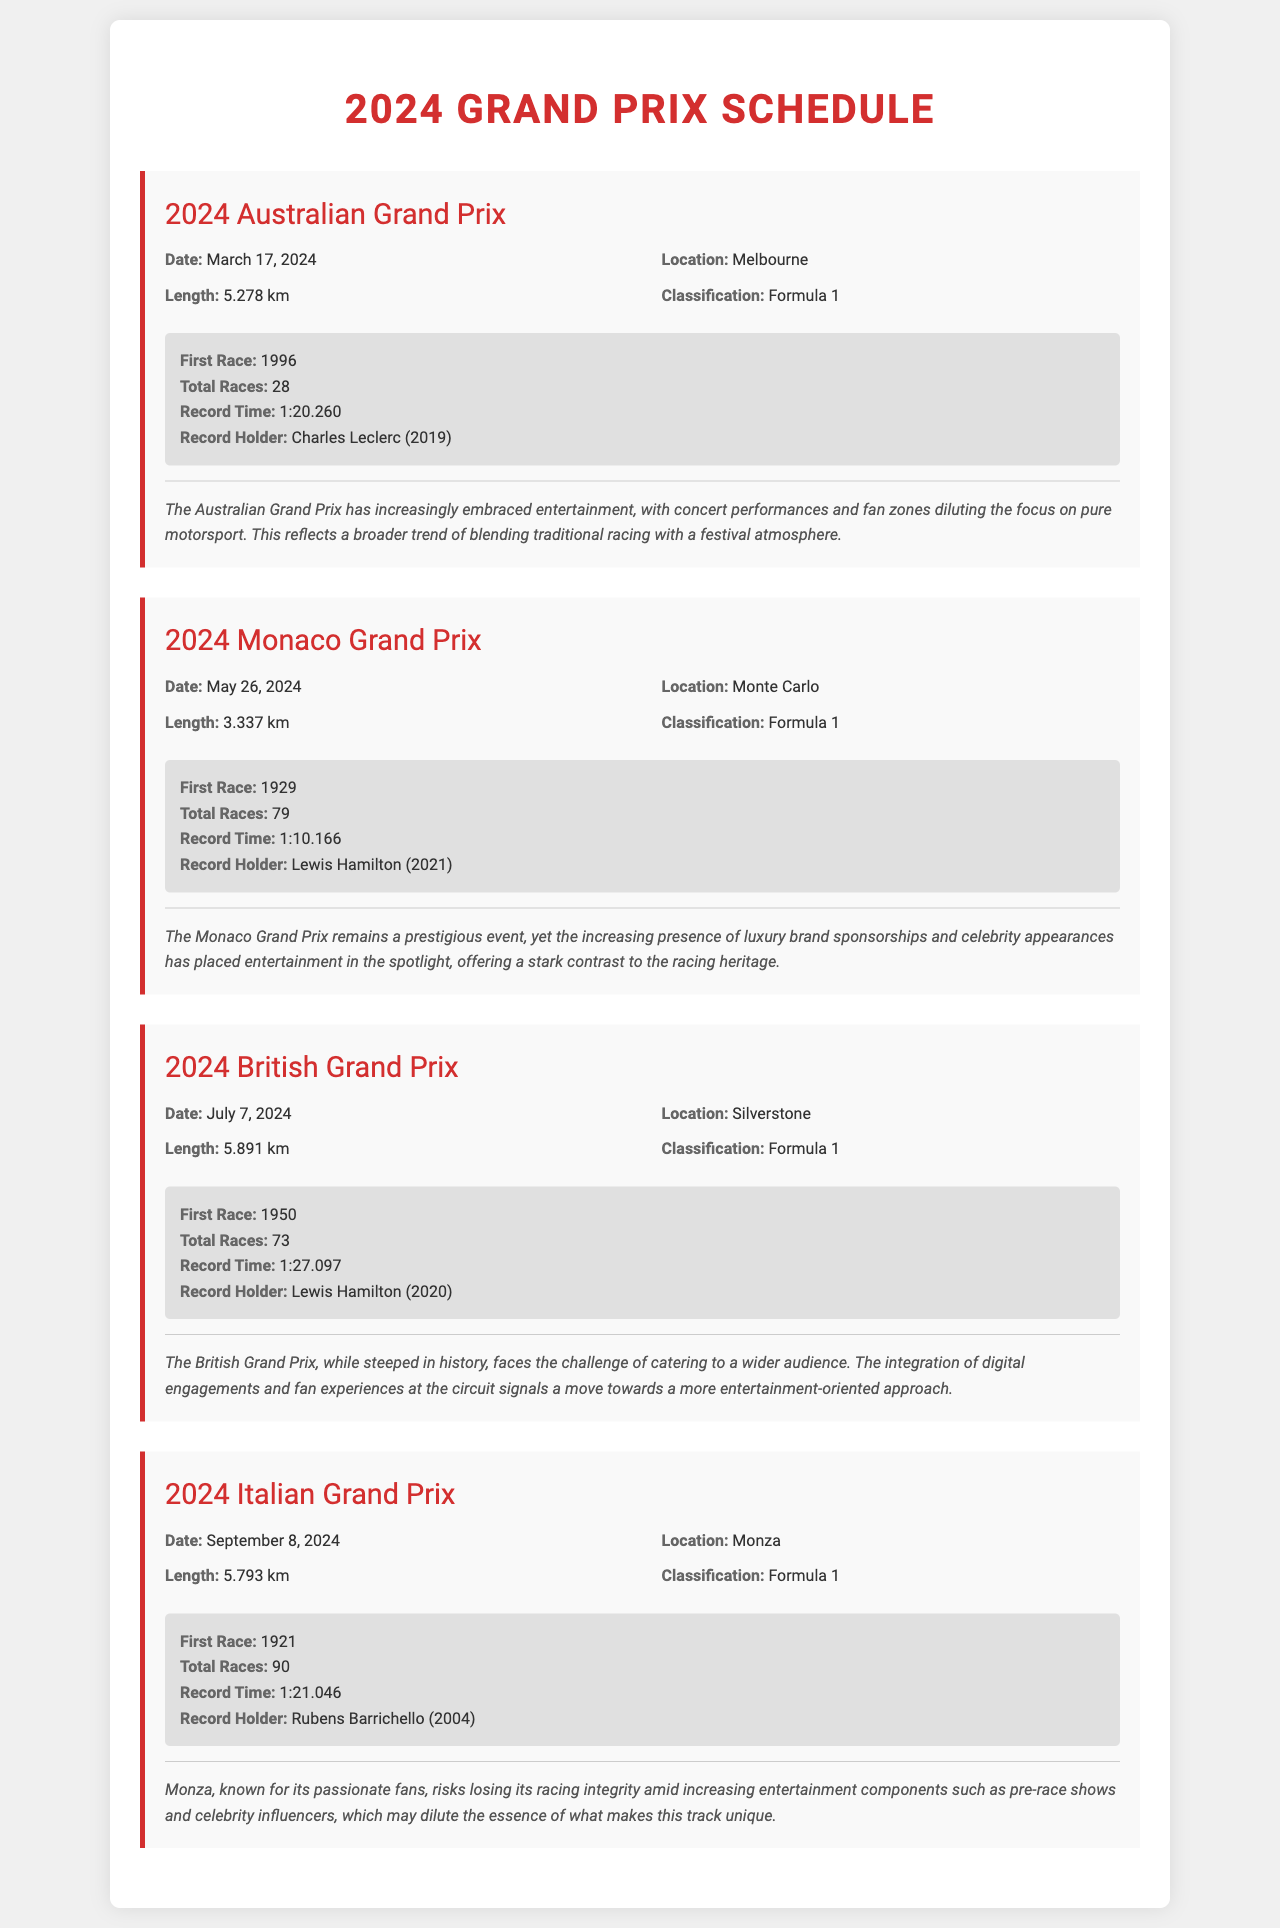what is the date of the 2024 Australian Grand Prix? The date is specified under the Australian Grand Prix section in the document.
Answer: March 17, 2024 who holds the record time for the 2024 Monaco Grand Prix? The record holder is listed in the Monaco Grand Prix section of the document.
Answer: Lewis Hamilton how many total races have occurred at the Italian Grand Prix? This information is provided in the historical section of the Italian Grand Prix card.
Answer: 90 what is the length of the British Grand Prix track? The length is detailed in the overview of the British Grand Prix section.
Answer: 5.891 km what year did the first race at Monza take place? The year of the first race is mentioned in the historical details of the Italian Grand Prix.
Answer: 1921 which Grand Prix has the shortest track length? This requires comparing the lengths of all the tracks mentioned in the document.
Answer: Monaco Grand Prix what type of events are becoming more common at the Australian Grand Prix? This information is discussed in the commentary section of the Australian Grand Prix card.
Answer: Concert performances how many races has the Monaco Grand Prix hosted? The total number of races is provided in the historical details of the Monaco Grand Prix card.
Answer: 79 what is the classification of the races in this document? The classification is mentioned consistently in all Grand Prix cards in the document.
Answer: Formula 1 